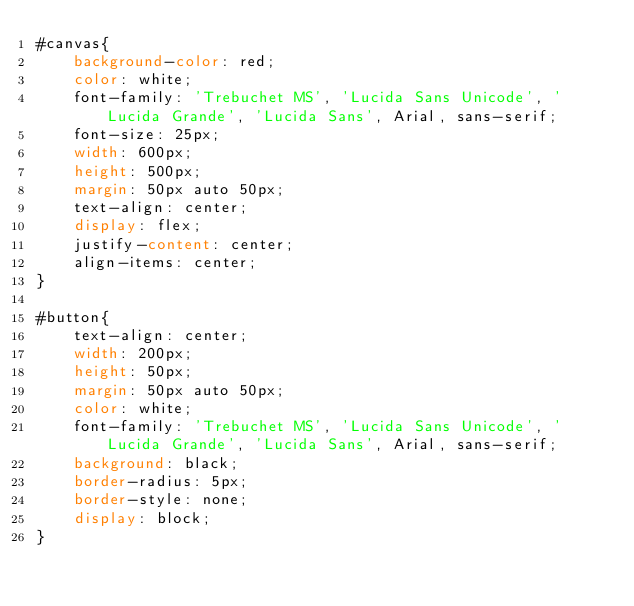<code> <loc_0><loc_0><loc_500><loc_500><_CSS_>#canvas{
    background-color: red;
    color: white;
    font-family: 'Trebuchet MS', 'Lucida Sans Unicode', 'Lucida Grande', 'Lucida Sans', Arial, sans-serif;
    font-size: 25px;
    width: 600px;
    height: 500px;
    margin: 50px auto 50px;
    text-align: center;
    display: flex;
    justify-content: center;
    align-items: center;
}

#button{
    text-align: center;
    width: 200px;
    height: 50px;
    margin: 50px auto 50px;
    color: white;
    font-family: 'Trebuchet MS', 'Lucida Sans Unicode', 'Lucida Grande', 'Lucida Sans', Arial, sans-serif;
    background: black;
    border-radius: 5px;
    border-style: none;
    display: block;
}
</code> 